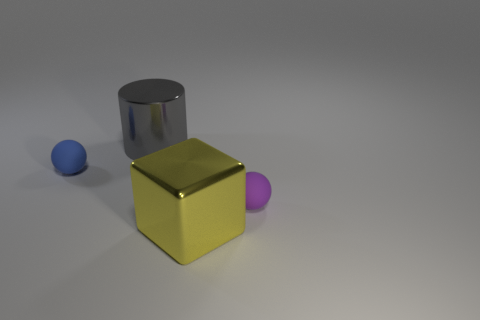The object that is behind the small object to the left of the sphere that is to the right of the yellow metal cube is made of what material? The object in question appears to be a cylinder with a reflective surface that suggests it is made of metal. Located at the back and to the left of the blue sphere, which itself is right of the yellow metal cube, the cylindrical object's material indicates a metallic composition due to its polished surface and reflective qualities. 